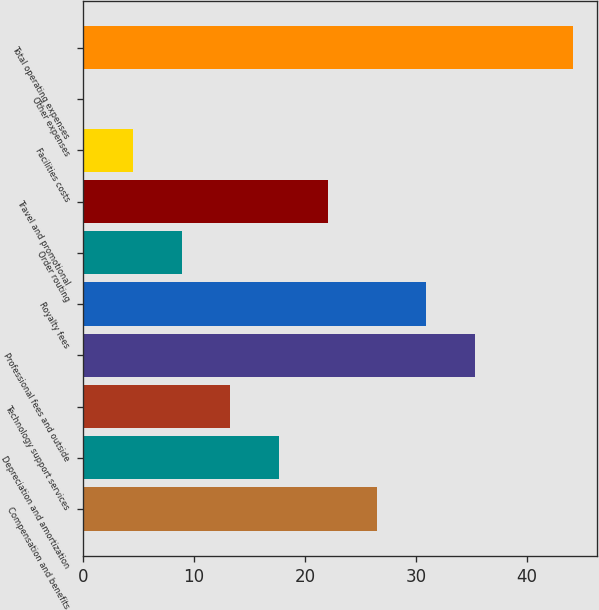Convert chart to OTSL. <chart><loc_0><loc_0><loc_500><loc_500><bar_chart><fcel>Compensation and benefits<fcel>Depreciation and amortization<fcel>Technology support services<fcel>Professional fees and outside<fcel>Royalty fees<fcel>Order routing<fcel>Travel and promotional<fcel>Facilities costs<fcel>Other expenses<fcel>Total operating expenses<nl><fcel>26.5<fcel>17.7<fcel>13.3<fcel>35.3<fcel>30.9<fcel>8.9<fcel>22.1<fcel>4.5<fcel>0.1<fcel>44.1<nl></chart> 